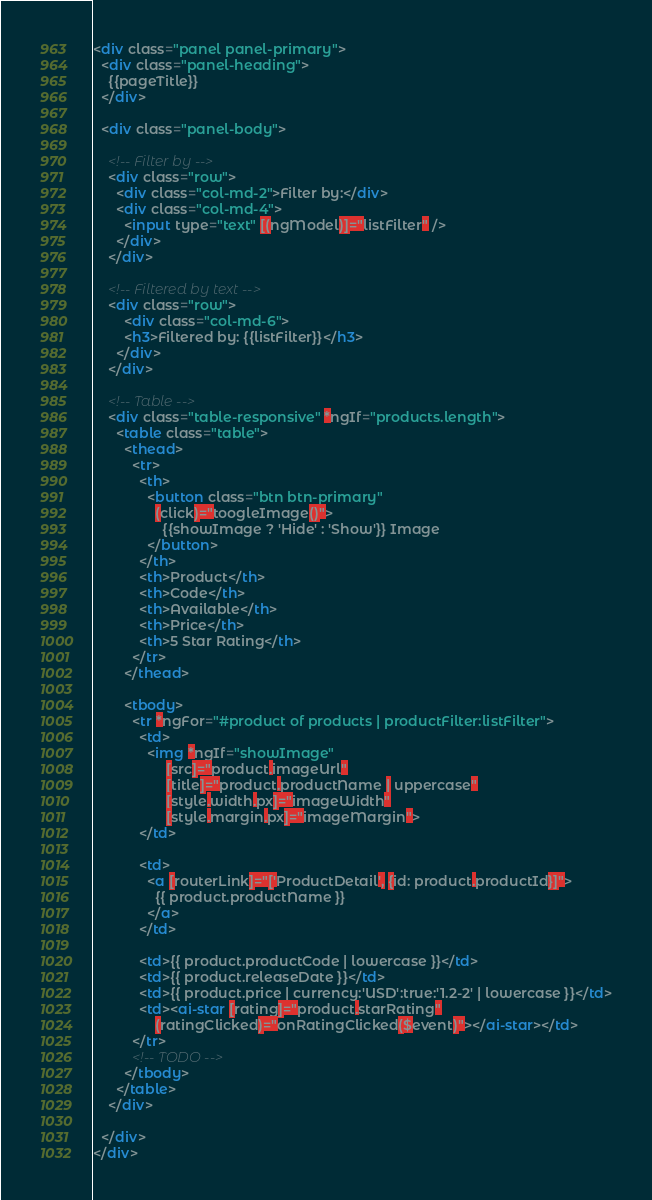<code> <loc_0><loc_0><loc_500><loc_500><_HTML_><div class="panel panel-primary">
  <div class="panel-heading">
    {{pageTitle}}
  </div>

  <div class="panel-body">

    <!-- Filter by -->
    <div class="row">
      <div class="col-md-2">Filter by:</div>
      <div class="col-md-4">
        <input type="text" [(ngModel)]="listFilter" />
      </div>
    </div>

    <!-- Filtered by text -->
    <div class="row">
        <div class="col-md-6">
        <h3>Filtered by: {{listFilter}}</h3>
      </div>
    </div>

    <!-- Table -->
    <div class="table-responsive" *ngIf="products.length">
      <table class="table">
        <thead> 
          <tr>
            <th>
              <button class="btn btn-primary"
                (click)="toogleImage()">
                  {{showImage ? 'Hide' : 'Show'}} Image
              </button>
            </th>
            <th>Product</th>
            <th>Code</th>
            <th>Available</th>
            <th>Price</th>
            <th>5 Star Rating</th>
          </tr>
        </thead>

        <tbody>
          <tr *ngFor="#product of products | productFilter:listFilter">
            <td>
              <img *ngIf="showImage"
                   [src]="product.imageUrl" 
                   [title]="product.productName | uppercase"
                   [style.width.px]="imageWidth"
                   [style.margin.px]="imageMargin">
            </td>
            
            <td>
              <a [routerLink]="['ProductDetail', {id: product.productId}]">
                {{ product.productName }}
              </a>
            </td>

            <td>{{ product.productCode | lowercase }}</td>
            <td>{{ product.releaseDate }}</td>
            <td>{{ product.price | currency:'USD':true:'1.2-2' | lowercase }}</td>
            <td><ai-star [rating]="product.starRating"
                (ratingClicked)="onRatingClicked($event)"></ai-star></td>
          </tr>
          <!-- TODO -->
        </tbody>
      </table>
    </div>

  </div>
</div></code> 